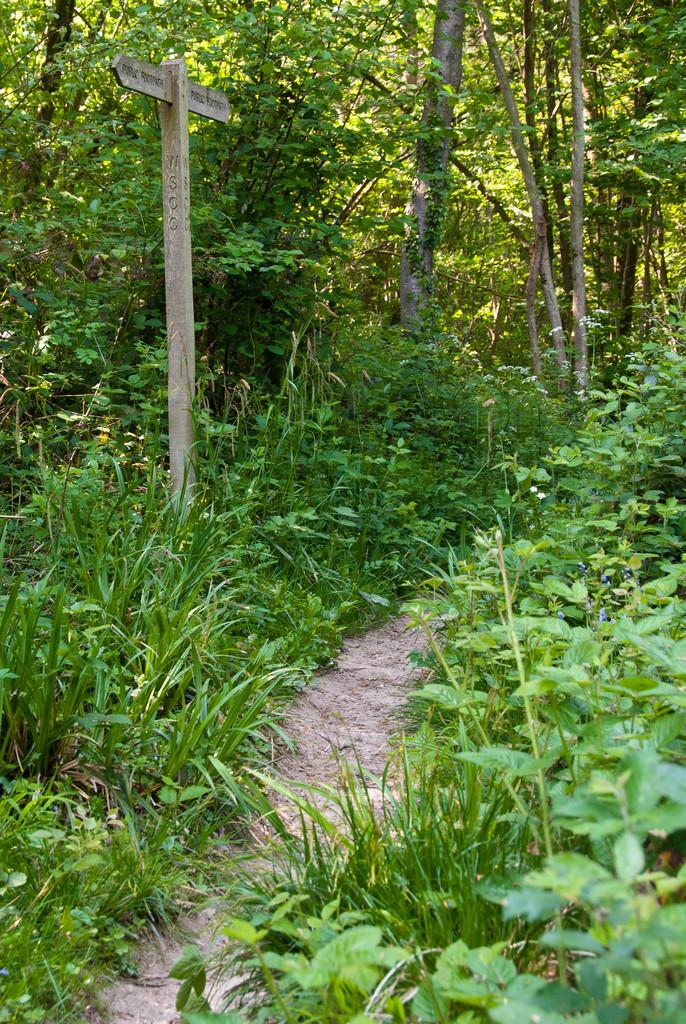What type of vegetation can be seen in the image? There is grass and trees in the image. What else is present in the image besides vegetation? There are boards in the image. What is written on the boards? Words are written on the boards. What type of cheese can be seen on the grass in the image? There is no cheese present in the image; it only features grass, trees, and boards with words written on them. 